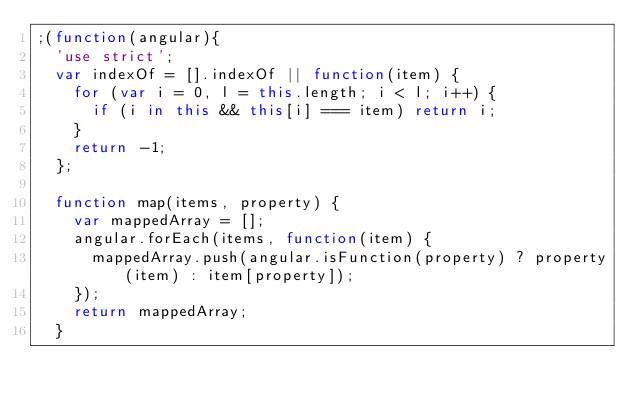<code> <loc_0><loc_0><loc_500><loc_500><_JavaScript_>;(function(angular){
  'use strict';
  var indexOf = [].indexOf || function(item) {
    for (var i = 0, l = this.length; i < l; i++) {
      if (i in this && this[i] === item) return i;
    }
    return -1;
  };

  function map(items, property) {
    var mappedArray = [];
    angular.forEach(items, function(item) {
      mappedArray.push(angular.isFunction(property) ? property(item) : item[property]);
    });
    return mappedArray;
  }
</code> 